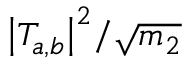<formula> <loc_0><loc_0><loc_500><loc_500>{ \left | T _ { a , b } \right | } ^ { 2 } / \sqrt { m _ { 2 } }</formula> 